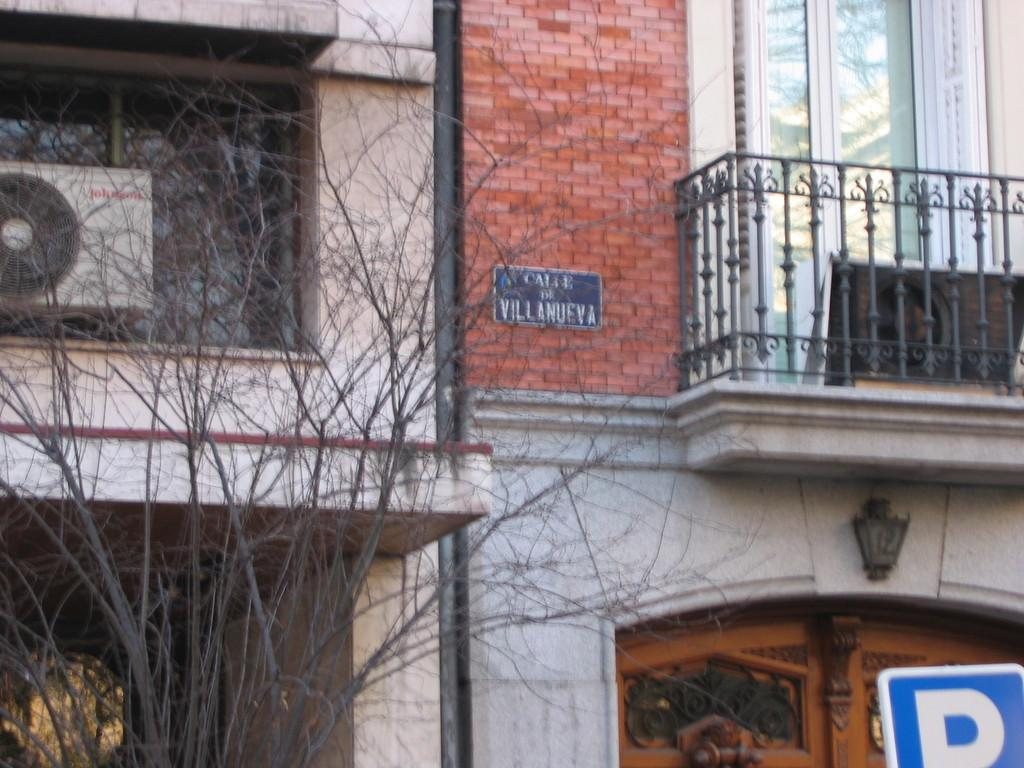What type of structures can be seen in the image? There are buildings in the image. What natural element is present in the image? There is a tree in the image. What architectural feature can be seen in the image? There is a railing in the image. What part of a building is visible in the image? There is a window in the image. What type of window treatment is present in the image? There are curtains in the image. What mechanical device is visible in the image? There is a compressor in the image. What flat, rigid object is present in the image? There is a board in the image. What type of text can be seen in the image? There is text in the image. What type of entrance is visible in the image? There is a door in the image. What type of signage is present in the image? There is a sign board in the image. What is the cook's opinion about the glue in the image? There is no cook or glue present in the image, so it is not possible to answer that question. 